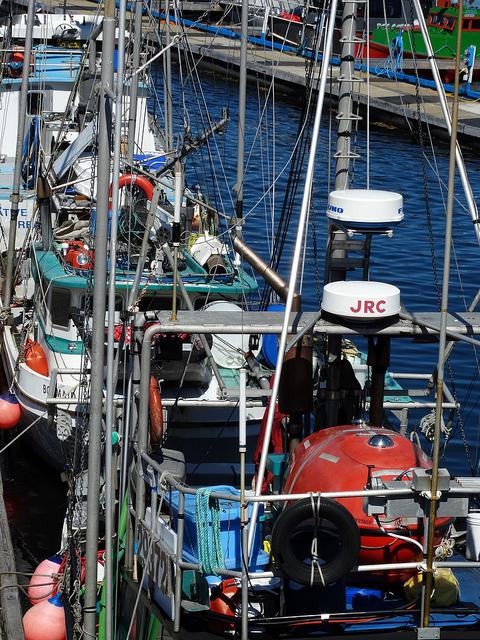What color are the round buoys on the left sides of these boats parked at the marina?

Choices:
A) orange
B) red
C) white
D) green red 